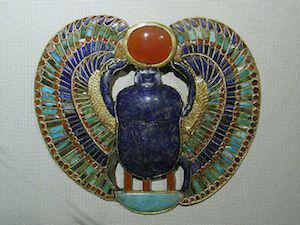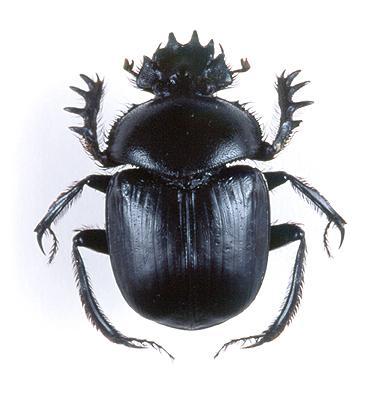The first image is the image on the left, the second image is the image on the right. For the images displayed, is the sentence "At least one image shows a single beetle that is iridescent green with iridescent red highlights." factually correct? Answer yes or no. No. 